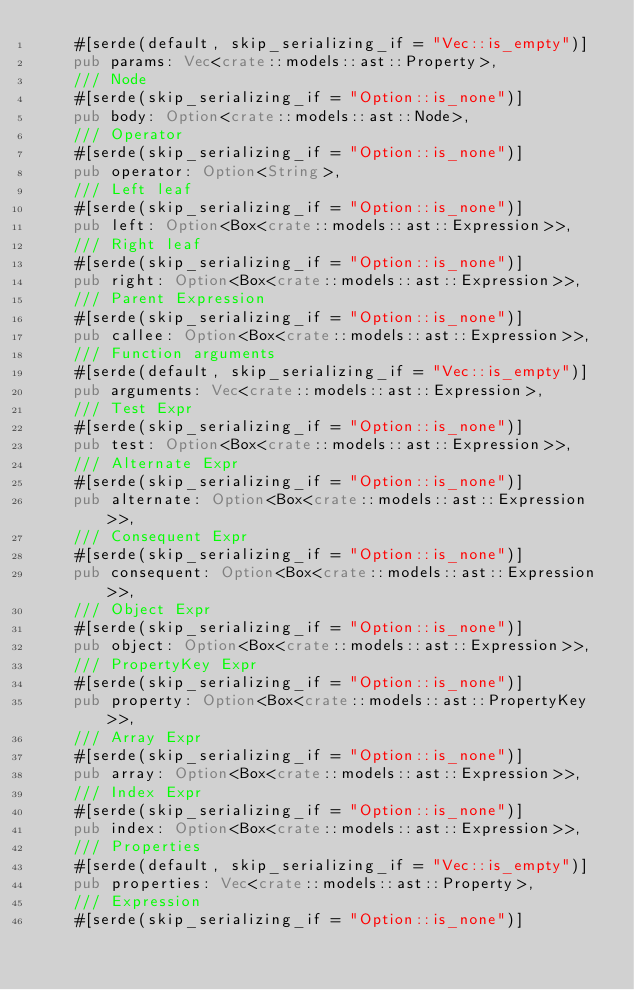<code> <loc_0><loc_0><loc_500><loc_500><_Rust_>    #[serde(default, skip_serializing_if = "Vec::is_empty")]
    pub params: Vec<crate::models::ast::Property>,
    /// Node
    #[serde(skip_serializing_if = "Option::is_none")]
    pub body: Option<crate::models::ast::Node>,
    /// Operator
    #[serde(skip_serializing_if = "Option::is_none")]
    pub operator: Option<String>,
    /// Left leaf
    #[serde(skip_serializing_if = "Option::is_none")]
    pub left: Option<Box<crate::models::ast::Expression>>,
    /// Right leaf
    #[serde(skip_serializing_if = "Option::is_none")]
    pub right: Option<Box<crate::models::ast::Expression>>,
    /// Parent Expression
    #[serde(skip_serializing_if = "Option::is_none")]
    pub callee: Option<Box<crate::models::ast::Expression>>,
    /// Function arguments
    #[serde(default, skip_serializing_if = "Vec::is_empty")]
    pub arguments: Vec<crate::models::ast::Expression>,
    /// Test Expr
    #[serde(skip_serializing_if = "Option::is_none")]
    pub test: Option<Box<crate::models::ast::Expression>>,
    /// Alternate Expr
    #[serde(skip_serializing_if = "Option::is_none")]
    pub alternate: Option<Box<crate::models::ast::Expression>>,
    /// Consequent Expr
    #[serde(skip_serializing_if = "Option::is_none")]
    pub consequent: Option<Box<crate::models::ast::Expression>>,
    /// Object Expr
    #[serde(skip_serializing_if = "Option::is_none")]
    pub object: Option<Box<crate::models::ast::Expression>>,
    /// PropertyKey Expr
    #[serde(skip_serializing_if = "Option::is_none")]
    pub property: Option<Box<crate::models::ast::PropertyKey>>,
    /// Array Expr
    #[serde(skip_serializing_if = "Option::is_none")]
    pub array: Option<Box<crate::models::ast::Expression>>,
    /// Index Expr
    #[serde(skip_serializing_if = "Option::is_none")]
    pub index: Option<Box<crate::models::ast::Expression>>,
    /// Properties
    #[serde(default, skip_serializing_if = "Vec::is_empty")]
    pub properties: Vec<crate::models::ast::Property>,
    /// Expression
    #[serde(skip_serializing_if = "Option::is_none")]</code> 